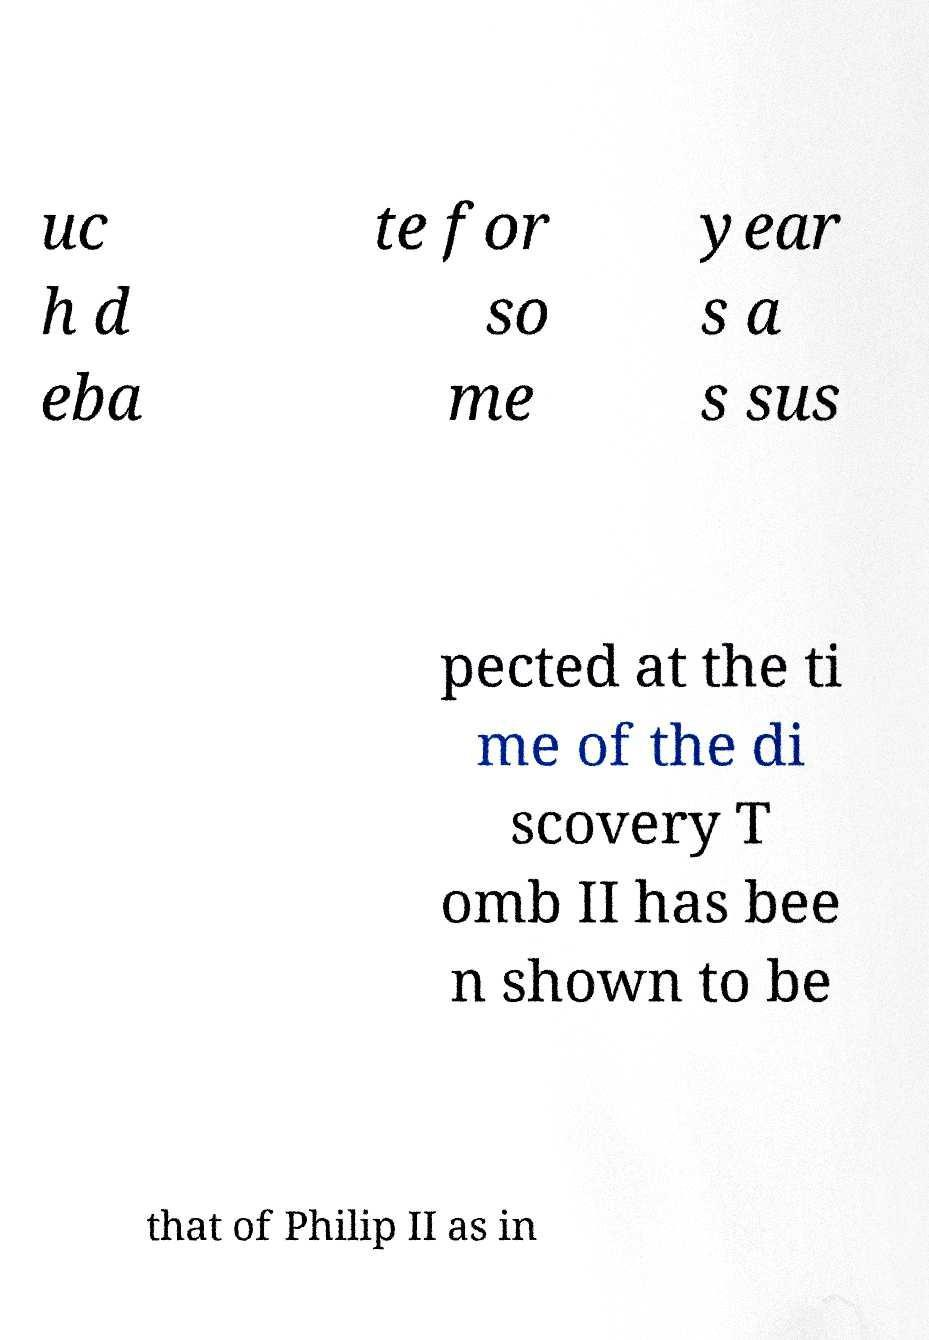Could you assist in decoding the text presented in this image and type it out clearly? uc h d eba te for so me year s a s sus pected at the ti me of the di scovery T omb II has bee n shown to be that of Philip II as in 